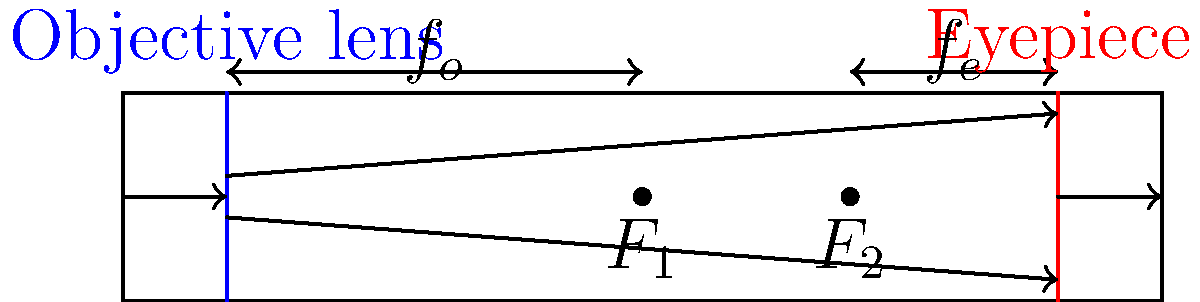As a country music enthusiast, you might appreciate the precision in tuning instruments. Similarly, telescopes require precise alignment of lenses. In a refracting telescope, how does the relationship between the focal lengths of the objective lens ($f_o$) and eyepiece ($f_e$) determine the magnification (M)? Let's break this down step-by-step, much like analyzing the components of a classic country song:

1. In a refracting telescope, there are two main lenses: the objective lens and the eyepiece.

2. The objective lens is the larger lens at the front of the telescope (blue in the diagram). It gathers light from distant objects and forms an image at its focal point ($F_1$).

3. The eyepiece is the smaller lens (red in the diagram) through which you look. It magnifies the image formed by the objective lens.

4. The magnification (M) of a telescope is determined by how much larger the image appears through the eyepiece compared to the naked eye.

5. Mathematically, the magnification is given by the ratio of the focal length of the objective lens ($f_o$) to the focal length of the eyepiece ($f_e$):

   $$M = \frac{f_o}{f_e}$$

6. This means that:
   - A longer focal length for the objective lens increases magnification.
   - A shorter focal length for the eyepiece increases magnification.

7. For example, if $f_o = 1000$ mm and $f_e = 10$ mm, the magnification would be:

   $$M = \frac{1000 \text{ mm}}{10 \text{ mm}} = 100\times$$

This relationship is similar to how changing the length of a guitar string affects its pitch - longer objective focal length (like a longer string) gives "lower" magnification, while a shorter eyepiece focal length (like a higher fret) gives "higher" magnification.
Answer: $M = \frac{f_o}{f_e}$ 